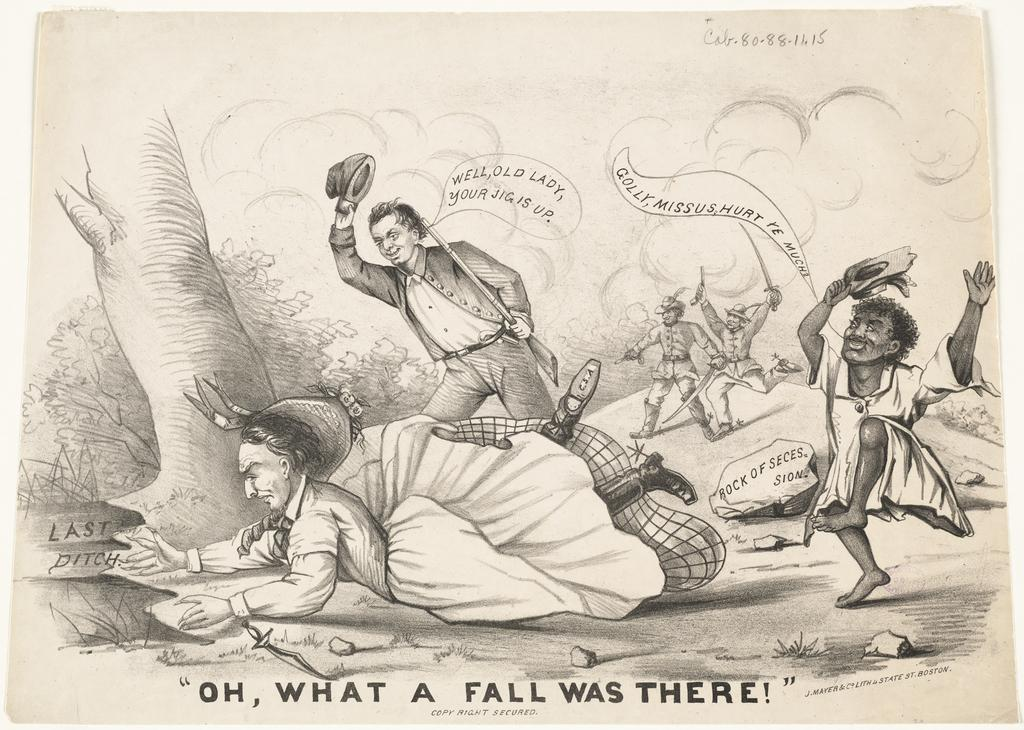What type of images are present in the picture? There are cartoon images in the picture. How is the picture presented? The picture appears to be printed. Is there any text present in the picture? Yes, there is text at the bottom of the picture and on the side of the images in the picture. What type of yarn is used to create the cartoon images in the picture? There is no yarn used to create the cartoon images in the picture, as they are likely created using digital or traditional illustration techniques. 